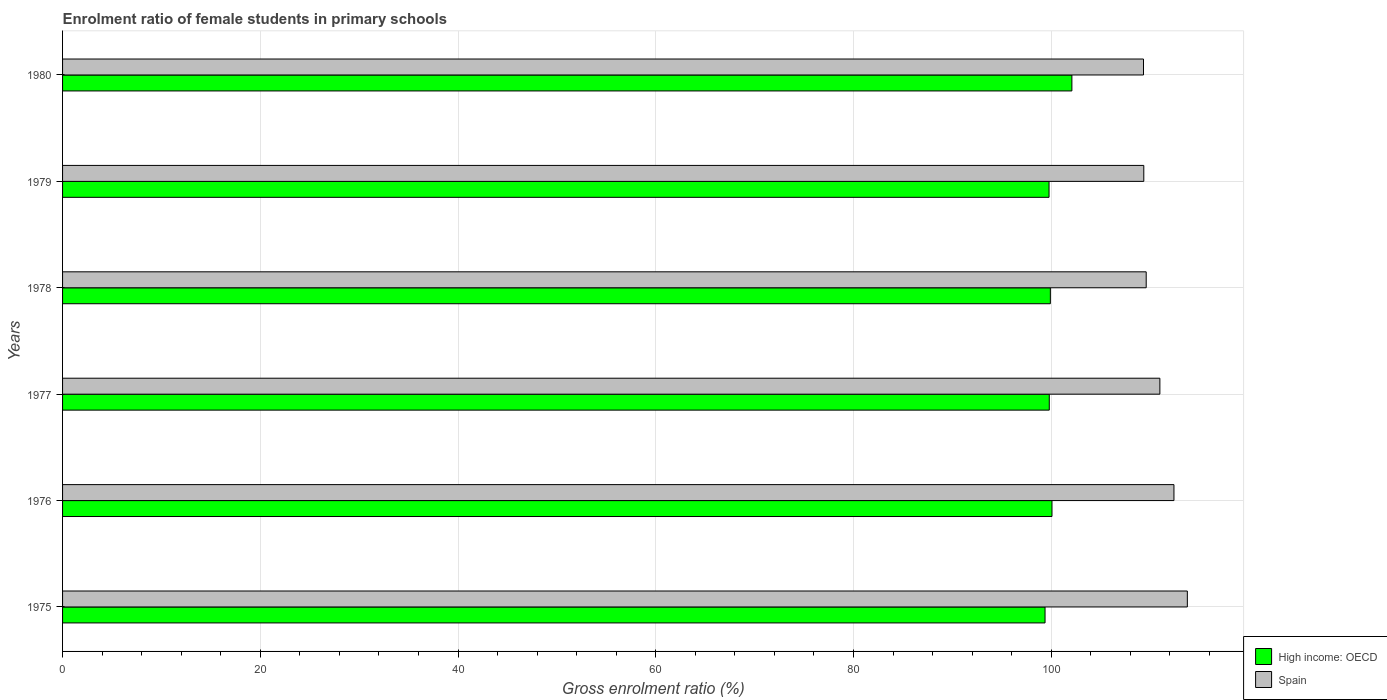How many different coloured bars are there?
Your answer should be very brief. 2. How many groups of bars are there?
Your answer should be compact. 6. Are the number of bars per tick equal to the number of legend labels?
Your answer should be very brief. Yes. Are the number of bars on each tick of the Y-axis equal?
Provide a succinct answer. Yes. How many bars are there on the 2nd tick from the top?
Provide a short and direct response. 2. How many bars are there on the 2nd tick from the bottom?
Your answer should be compact. 2. What is the label of the 3rd group of bars from the top?
Provide a succinct answer. 1978. What is the enrolment ratio of female students in primary schools in Spain in 1976?
Provide a succinct answer. 112.41. Across all years, what is the maximum enrolment ratio of female students in primary schools in Spain?
Your answer should be compact. 113.77. Across all years, what is the minimum enrolment ratio of female students in primary schools in Spain?
Offer a terse response. 109.33. In which year was the enrolment ratio of female students in primary schools in Spain maximum?
Your answer should be very brief. 1975. In which year was the enrolment ratio of female students in primary schools in Spain minimum?
Your answer should be compact. 1980. What is the total enrolment ratio of female students in primary schools in Spain in the graph?
Make the answer very short. 665.48. What is the difference between the enrolment ratio of female students in primary schools in High income: OECD in 1976 and that in 1979?
Provide a succinct answer. 0.3. What is the difference between the enrolment ratio of female students in primary schools in High income: OECD in 1975 and the enrolment ratio of female students in primary schools in Spain in 1976?
Make the answer very short. -13.04. What is the average enrolment ratio of female students in primary schools in High income: OECD per year?
Offer a terse response. 100.17. In the year 1979, what is the difference between the enrolment ratio of female students in primary schools in High income: OECD and enrolment ratio of female students in primary schools in Spain?
Make the answer very short. -9.58. In how many years, is the enrolment ratio of female students in primary schools in Spain greater than 80 %?
Keep it short and to the point. 6. What is the ratio of the enrolment ratio of female students in primary schools in High income: OECD in 1975 to that in 1979?
Make the answer very short. 1. Is the enrolment ratio of female students in primary schools in Spain in 1979 less than that in 1980?
Your response must be concise. No. What is the difference between the highest and the second highest enrolment ratio of female students in primary schools in High income: OECD?
Provide a short and direct response. 2.01. What is the difference between the highest and the lowest enrolment ratio of female students in primary schools in High income: OECD?
Ensure brevity in your answer.  2.72. In how many years, is the enrolment ratio of female students in primary schools in High income: OECD greater than the average enrolment ratio of female students in primary schools in High income: OECD taken over all years?
Keep it short and to the point. 1. What does the 2nd bar from the top in 1976 represents?
Offer a terse response. High income: OECD. What does the 1st bar from the bottom in 1979 represents?
Give a very brief answer. High income: OECD. How many bars are there?
Provide a short and direct response. 12. How many years are there in the graph?
Keep it short and to the point. 6. Are the values on the major ticks of X-axis written in scientific E-notation?
Provide a short and direct response. No. Does the graph contain any zero values?
Provide a succinct answer. No. Does the graph contain grids?
Give a very brief answer. Yes. Where does the legend appear in the graph?
Your answer should be compact. Bottom right. What is the title of the graph?
Ensure brevity in your answer.  Enrolment ratio of female students in primary schools. Does "North America" appear as one of the legend labels in the graph?
Give a very brief answer. No. What is the label or title of the X-axis?
Make the answer very short. Gross enrolment ratio (%). What is the Gross enrolment ratio (%) in High income: OECD in 1975?
Your answer should be very brief. 99.38. What is the Gross enrolment ratio (%) of Spain in 1975?
Provide a succinct answer. 113.77. What is the Gross enrolment ratio (%) of High income: OECD in 1976?
Give a very brief answer. 100.08. What is the Gross enrolment ratio (%) of Spain in 1976?
Ensure brevity in your answer.  112.41. What is the Gross enrolment ratio (%) of High income: OECD in 1977?
Make the answer very short. 99.8. What is the Gross enrolment ratio (%) of Spain in 1977?
Offer a very short reply. 110.99. What is the Gross enrolment ratio (%) in High income: OECD in 1978?
Give a very brief answer. 99.91. What is the Gross enrolment ratio (%) in Spain in 1978?
Provide a succinct answer. 109.61. What is the Gross enrolment ratio (%) of High income: OECD in 1979?
Provide a succinct answer. 99.78. What is the Gross enrolment ratio (%) in Spain in 1979?
Make the answer very short. 109.36. What is the Gross enrolment ratio (%) in High income: OECD in 1980?
Keep it short and to the point. 102.09. What is the Gross enrolment ratio (%) of Spain in 1980?
Your answer should be very brief. 109.33. Across all years, what is the maximum Gross enrolment ratio (%) in High income: OECD?
Ensure brevity in your answer.  102.09. Across all years, what is the maximum Gross enrolment ratio (%) of Spain?
Offer a terse response. 113.77. Across all years, what is the minimum Gross enrolment ratio (%) in High income: OECD?
Your answer should be very brief. 99.38. Across all years, what is the minimum Gross enrolment ratio (%) in Spain?
Your answer should be compact. 109.33. What is the total Gross enrolment ratio (%) of High income: OECD in the graph?
Provide a short and direct response. 601.04. What is the total Gross enrolment ratio (%) of Spain in the graph?
Provide a succinct answer. 665.48. What is the difference between the Gross enrolment ratio (%) of High income: OECD in 1975 and that in 1976?
Ensure brevity in your answer.  -0.7. What is the difference between the Gross enrolment ratio (%) of Spain in 1975 and that in 1976?
Ensure brevity in your answer.  1.35. What is the difference between the Gross enrolment ratio (%) in High income: OECD in 1975 and that in 1977?
Give a very brief answer. -0.43. What is the difference between the Gross enrolment ratio (%) in Spain in 1975 and that in 1977?
Provide a short and direct response. 2.78. What is the difference between the Gross enrolment ratio (%) of High income: OECD in 1975 and that in 1978?
Provide a short and direct response. -0.54. What is the difference between the Gross enrolment ratio (%) of Spain in 1975 and that in 1978?
Provide a short and direct response. 4.16. What is the difference between the Gross enrolment ratio (%) of High income: OECD in 1975 and that in 1979?
Make the answer very short. -0.4. What is the difference between the Gross enrolment ratio (%) in Spain in 1975 and that in 1979?
Make the answer very short. 4.4. What is the difference between the Gross enrolment ratio (%) of High income: OECD in 1975 and that in 1980?
Your answer should be compact. -2.72. What is the difference between the Gross enrolment ratio (%) in Spain in 1975 and that in 1980?
Your answer should be very brief. 4.43. What is the difference between the Gross enrolment ratio (%) in High income: OECD in 1976 and that in 1977?
Keep it short and to the point. 0.27. What is the difference between the Gross enrolment ratio (%) in Spain in 1976 and that in 1977?
Your answer should be very brief. 1.42. What is the difference between the Gross enrolment ratio (%) of High income: OECD in 1976 and that in 1978?
Keep it short and to the point. 0.17. What is the difference between the Gross enrolment ratio (%) of Spain in 1976 and that in 1978?
Provide a short and direct response. 2.81. What is the difference between the Gross enrolment ratio (%) of High income: OECD in 1976 and that in 1979?
Offer a terse response. 0.3. What is the difference between the Gross enrolment ratio (%) in Spain in 1976 and that in 1979?
Your answer should be very brief. 3.05. What is the difference between the Gross enrolment ratio (%) in High income: OECD in 1976 and that in 1980?
Ensure brevity in your answer.  -2.01. What is the difference between the Gross enrolment ratio (%) of Spain in 1976 and that in 1980?
Make the answer very short. 3.08. What is the difference between the Gross enrolment ratio (%) in High income: OECD in 1977 and that in 1978?
Your response must be concise. -0.11. What is the difference between the Gross enrolment ratio (%) in Spain in 1977 and that in 1978?
Keep it short and to the point. 1.38. What is the difference between the Gross enrolment ratio (%) of High income: OECD in 1977 and that in 1979?
Provide a short and direct response. 0.02. What is the difference between the Gross enrolment ratio (%) of Spain in 1977 and that in 1979?
Keep it short and to the point. 1.63. What is the difference between the Gross enrolment ratio (%) of High income: OECD in 1977 and that in 1980?
Provide a short and direct response. -2.29. What is the difference between the Gross enrolment ratio (%) of Spain in 1977 and that in 1980?
Keep it short and to the point. 1.66. What is the difference between the Gross enrolment ratio (%) in High income: OECD in 1978 and that in 1979?
Your answer should be compact. 0.13. What is the difference between the Gross enrolment ratio (%) of Spain in 1978 and that in 1979?
Your response must be concise. 0.24. What is the difference between the Gross enrolment ratio (%) of High income: OECD in 1978 and that in 1980?
Your response must be concise. -2.18. What is the difference between the Gross enrolment ratio (%) of Spain in 1978 and that in 1980?
Your response must be concise. 0.27. What is the difference between the Gross enrolment ratio (%) of High income: OECD in 1979 and that in 1980?
Provide a succinct answer. -2.31. What is the difference between the Gross enrolment ratio (%) in Spain in 1979 and that in 1980?
Provide a short and direct response. 0.03. What is the difference between the Gross enrolment ratio (%) of High income: OECD in 1975 and the Gross enrolment ratio (%) of Spain in 1976?
Keep it short and to the point. -13.04. What is the difference between the Gross enrolment ratio (%) in High income: OECD in 1975 and the Gross enrolment ratio (%) in Spain in 1977?
Provide a short and direct response. -11.61. What is the difference between the Gross enrolment ratio (%) of High income: OECD in 1975 and the Gross enrolment ratio (%) of Spain in 1978?
Give a very brief answer. -10.23. What is the difference between the Gross enrolment ratio (%) in High income: OECD in 1975 and the Gross enrolment ratio (%) in Spain in 1979?
Your answer should be very brief. -9.99. What is the difference between the Gross enrolment ratio (%) in High income: OECD in 1975 and the Gross enrolment ratio (%) in Spain in 1980?
Your answer should be very brief. -9.96. What is the difference between the Gross enrolment ratio (%) in High income: OECD in 1976 and the Gross enrolment ratio (%) in Spain in 1977?
Keep it short and to the point. -10.91. What is the difference between the Gross enrolment ratio (%) in High income: OECD in 1976 and the Gross enrolment ratio (%) in Spain in 1978?
Ensure brevity in your answer.  -9.53. What is the difference between the Gross enrolment ratio (%) of High income: OECD in 1976 and the Gross enrolment ratio (%) of Spain in 1979?
Your answer should be very brief. -9.29. What is the difference between the Gross enrolment ratio (%) in High income: OECD in 1976 and the Gross enrolment ratio (%) in Spain in 1980?
Keep it short and to the point. -9.26. What is the difference between the Gross enrolment ratio (%) of High income: OECD in 1977 and the Gross enrolment ratio (%) of Spain in 1978?
Ensure brevity in your answer.  -9.8. What is the difference between the Gross enrolment ratio (%) in High income: OECD in 1977 and the Gross enrolment ratio (%) in Spain in 1979?
Make the answer very short. -9.56. What is the difference between the Gross enrolment ratio (%) of High income: OECD in 1977 and the Gross enrolment ratio (%) of Spain in 1980?
Offer a terse response. -9.53. What is the difference between the Gross enrolment ratio (%) of High income: OECD in 1978 and the Gross enrolment ratio (%) of Spain in 1979?
Your response must be concise. -9.45. What is the difference between the Gross enrolment ratio (%) of High income: OECD in 1978 and the Gross enrolment ratio (%) of Spain in 1980?
Your response must be concise. -9.42. What is the difference between the Gross enrolment ratio (%) in High income: OECD in 1979 and the Gross enrolment ratio (%) in Spain in 1980?
Your response must be concise. -9.55. What is the average Gross enrolment ratio (%) of High income: OECD per year?
Your answer should be compact. 100.17. What is the average Gross enrolment ratio (%) in Spain per year?
Your answer should be compact. 110.91. In the year 1975, what is the difference between the Gross enrolment ratio (%) of High income: OECD and Gross enrolment ratio (%) of Spain?
Provide a short and direct response. -14.39. In the year 1976, what is the difference between the Gross enrolment ratio (%) in High income: OECD and Gross enrolment ratio (%) in Spain?
Offer a terse response. -12.34. In the year 1977, what is the difference between the Gross enrolment ratio (%) of High income: OECD and Gross enrolment ratio (%) of Spain?
Offer a very short reply. -11.19. In the year 1978, what is the difference between the Gross enrolment ratio (%) of High income: OECD and Gross enrolment ratio (%) of Spain?
Your answer should be compact. -9.69. In the year 1979, what is the difference between the Gross enrolment ratio (%) of High income: OECD and Gross enrolment ratio (%) of Spain?
Ensure brevity in your answer.  -9.58. In the year 1980, what is the difference between the Gross enrolment ratio (%) of High income: OECD and Gross enrolment ratio (%) of Spain?
Offer a terse response. -7.24. What is the ratio of the Gross enrolment ratio (%) in High income: OECD in 1975 to that in 1977?
Make the answer very short. 1. What is the ratio of the Gross enrolment ratio (%) of Spain in 1975 to that in 1978?
Give a very brief answer. 1.04. What is the ratio of the Gross enrolment ratio (%) in Spain in 1975 to that in 1979?
Offer a very short reply. 1.04. What is the ratio of the Gross enrolment ratio (%) in High income: OECD in 1975 to that in 1980?
Provide a succinct answer. 0.97. What is the ratio of the Gross enrolment ratio (%) in Spain in 1975 to that in 1980?
Offer a terse response. 1.04. What is the ratio of the Gross enrolment ratio (%) in High income: OECD in 1976 to that in 1977?
Provide a succinct answer. 1. What is the ratio of the Gross enrolment ratio (%) of Spain in 1976 to that in 1977?
Offer a very short reply. 1.01. What is the ratio of the Gross enrolment ratio (%) in High income: OECD in 1976 to that in 1978?
Provide a succinct answer. 1. What is the ratio of the Gross enrolment ratio (%) in Spain in 1976 to that in 1978?
Offer a very short reply. 1.03. What is the ratio of the Gross enrolment ratio (%) of High income: OECD in 1976 to that in 1979?
Offer a very short reply. 1. What is the ratio of the Gross enrolment ratio (%) of Spain in 1976 to that in 1979?
Provide a succinct answer. 1.03. What is the ratio of the Gross enrolment ratio (%) in High income: OECD in 1976 to that in 1980?
Your answer should be compact. 0.98. What is the ratio of the Gross enrolment ratio (%) in Spain in 1976 to that in 1980?
Provide a succinct answer. 1.03. What is the ratio of the Gross enrolment ratio (%) in High income: OECD in 1977 to that in 1978?
Offer a very short reply. 1. What is the ratio of the Gross enrolment ratio (%) in Spain in 1977 to that in 1978?
Offer a very short reply. 1.01. What is the ratio of the Gross enrolment ratio (%) of Spain in 1977 to that in 1979?
Your answer should be compact. 1.01. What is the ratio of the Gross enrolment ratio (%) in High income: OECD in 1977 to that in 1980?
Make the answer very short. 0.98. What is the ratio of the Gross enrolment ratio (%) of Spain in 1977 to that in 1980?
Provide a succinct answer. 1.02. What is the ratio of the Gross enrolment ratio (%) of Spain in 1978 to that in 1979?
Make the answer very short. 1. What is the ratio of the Gross enrolment ratio (%) of High income: OECD in 1978 to that in 1980?
Offer a very short reply. 0.98. What is the ratio of the Gross enrolment ratio (%) in High income: OECD in 1979 to that in 1980?
Ensure brevity in your answer.  0.98. What is the difference between the highest and the second highest Gross enrolment ratio (%) of High income: OECD?
Offer a terse response. 2.01. What is the difference between the highest and the second highest Gross enrolment ratio (%) in Spain?
Offer a terse response. 1.35. What is the difference between the highest and the lowest Gross enrolment ratio (%) in High income: OECD?
Offer a terse response. 2.72. What is the difference between the highest and the lowest Gross enrolment ratio (%) of Spain?
Make the answer very short. 4.43. 